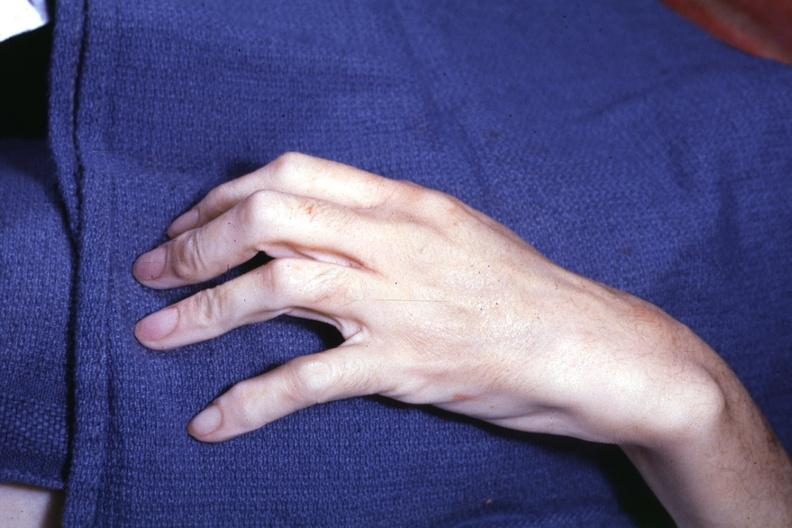what see other slides?
Answer the question using a single word or phrase. Interesting case 